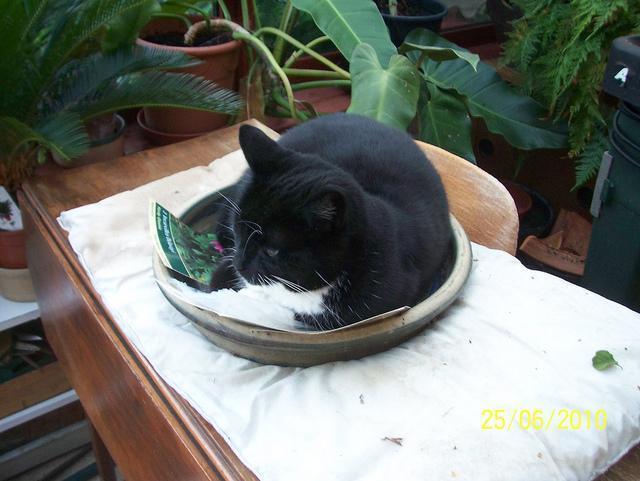How many cats are in the image?
Give a very brief answer. 1. How many potted plants are in the photo?
Give a very brief answer. 5. 